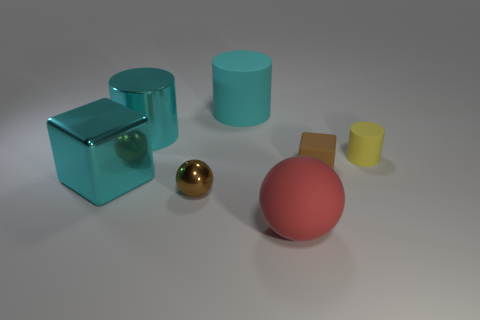Subtract all big cyan cylinders. How many cylinders are left? 1 Subtract all yellow cylinders. How many cylinders are left? 2 Subtract all blue cubes. How many brown spheres are left? 1 Subtract all cubes. How many objects are left? 5 Subtract all large brown shiny cylinders. Subtract all big rubber things. How many objects are left? 5 Add 3 small brown rubber things. How many small brown rubber things are left? 4 Add 5 large cylinders. How many large cylinders exist? 7 Add 3 large red spheres. How many objects exist? 10 Subtract 0 green balls. How many objects are left? 7 Subtract 1 blocks. How many blocks are left? 1 